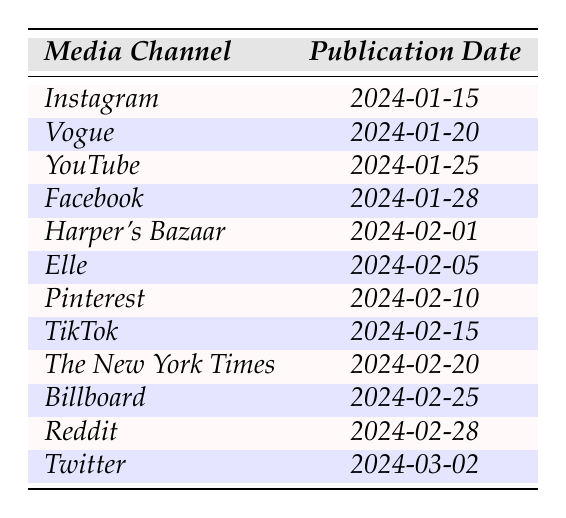What is the first media channel to publish in the campaign? The first media channel listed in the table is Instagram, which has a publication date of 2024-01-15.
Answer: Instagram When does Vogue's publication date occur? According to the table, Vogue's publication date is stated as 2024-01-20.
Answer: 2024-01-20 Which media channel is scheduled for publication on February 25, 2024? By checking the table, Billboard is the media channel that is set to publish on 2024-02-25.
Answer: Billboard Is TikTok publishing before Harper's Bazaar? TikTok's publication date is 2024-02-15 and Harper's Bazaar's is 2024-02-01; therefore, TikTok is not publishing before Harper's Bazaar.
Answer: No What is the total number of media channels listed in the table? The table shows 12 media channels listed that are scheduled for publication.
Answer: 12 On how many occasions is the publication scheduled for February? By counting the entries for February in the table, there are 6 publication dates that fall within that month.
Answer: 6 Which media channel has the latest publication date, and what is that date? The last entry in the table is Twitter, scheduled for publication on 2024-03-02, making it the latest.
Answer: Twitter, 2024-03-02 List the media channels that publish in the second half of February. Referring to the table, the media channels that publish from February 15 onwards are TikTok, The New York Times, Billboard, Reddit, and Twitter, totaling five.
Answer: TikTok, The New York Times, Billboard, Reddit, Twitter What is the average publication day of all the media channels listed? Counting all the publication days (dates) and finding the average would require summing those days (15 + 20 + 25 + 28 + 1 + 5 + 10 + 15 + 20 + 25 + 28 + 2 = 15.5), and there are 12 media channels. Thus, the average is 15.5.
Answer: 15.5 Are there any media channels that publish in January? Yes, the media channels Instagram, Vogue, and YouTube are all scheduled to publish in January.
Answer: Yes 